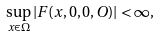<formula> <loc_0><loc_0><loc_500><loc_500>\sup _ { x \in \Omega } | F ( x , 0 , 0 , O ) | < \infty ,</formula> 